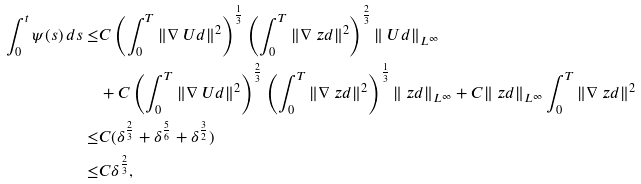Convert formula to latex. <formula><loc_0><loc_0><loc_500><loc_500>\int _ { 0 } ^ { t } \psi ( s ) \, d s \leq & C \left ( \int _ { 0 } ^ { T } \| \nabla \ U d \| ^ { 2 } \right ) ^ { \frac { 1 } { 3 } } \left ( \int _ { 0 } ^ { T } \| \nabla \ z d \| ^ { 2 } \right ) ^ { \frac { 2 } { 3 } } \| \ U d \| _ { L ^ { \infty } } \\ & + C \left ( \int _ { 0 } ^ { T } \| \nabla \ U d \| ^ { 2 } \right ) ^ { \frac { 2 } { 3 } } \left ( \int _ { 0 } ^ { T } \| \nabla \ z d \| ^ { 2 } \right ) ^ { \frac { 1 } { 3 } } \| \ z d \| _ { L ^ { \infty } } + C \| \ z d \| _ { L ^ { \infty } } \int _ { 0 } ^ { T } \| \nabla \ z d \| ^ { 2 } \\ \leq & C ( \delta ^ { \frac { 2 } { 3 } } + \delta ^ { \frac { 5 } { 6 } } + \delta ^ { \frac { 3 } { 2 } } ) \\ \leq & C \delta ^ { \frac { 2 } { 3 } } ,</formula> 